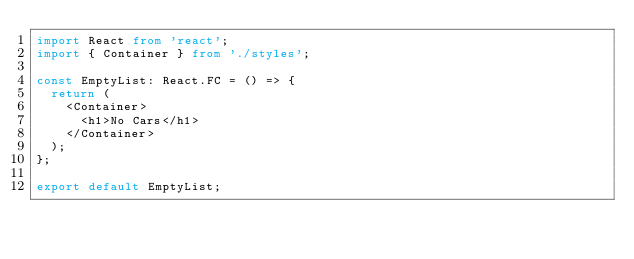Convert code to text. <code><loc_0><loc_0><loc_500><loc_500><_TypeScript_>import React from 'react';
import { Container } from './styles';

const EmptyList: React.FC = () => {
  return (
    <Container>
      <h1>No Cars</h1>
    </Container>
  );
};

export default EmptyList;
</code> 